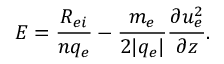Convert formula to latex. <formula><loc_0><loc_0><loc_500><loc_500>E = \frac { R _ { e i } } { n q _ { e } } - \frac { m _ { e } } { 2 | q _ { e } | } \frac { \partial u _ { e } ^ { 2 } } { \partial z } .</formula> 